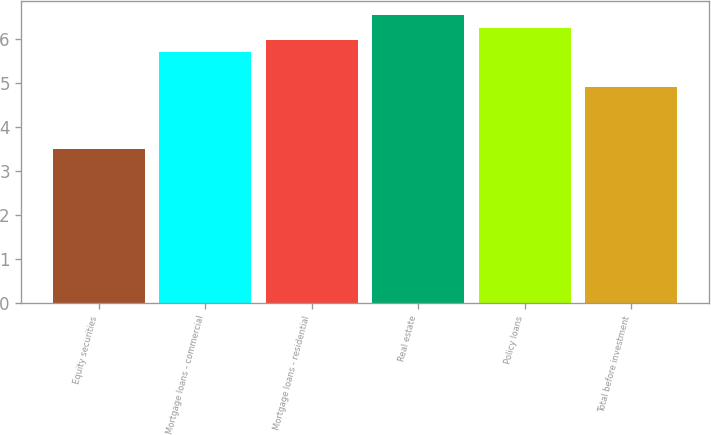Convert chart. <chart><loc_0><loc_0><loc_500><loc_500><bar_chart><fcel>Equity securities<fcel>Mortgage loans - commercial<fcel>Mortgage loans - residential<fcel>Real estate<fcel>Policy loans<fcel>Total before investment<nl><fcel>3.5<fcel>5.7<fcel>5.98<fcel>6.54<fcel>6.26<fcel>4.9<nl></chart> 